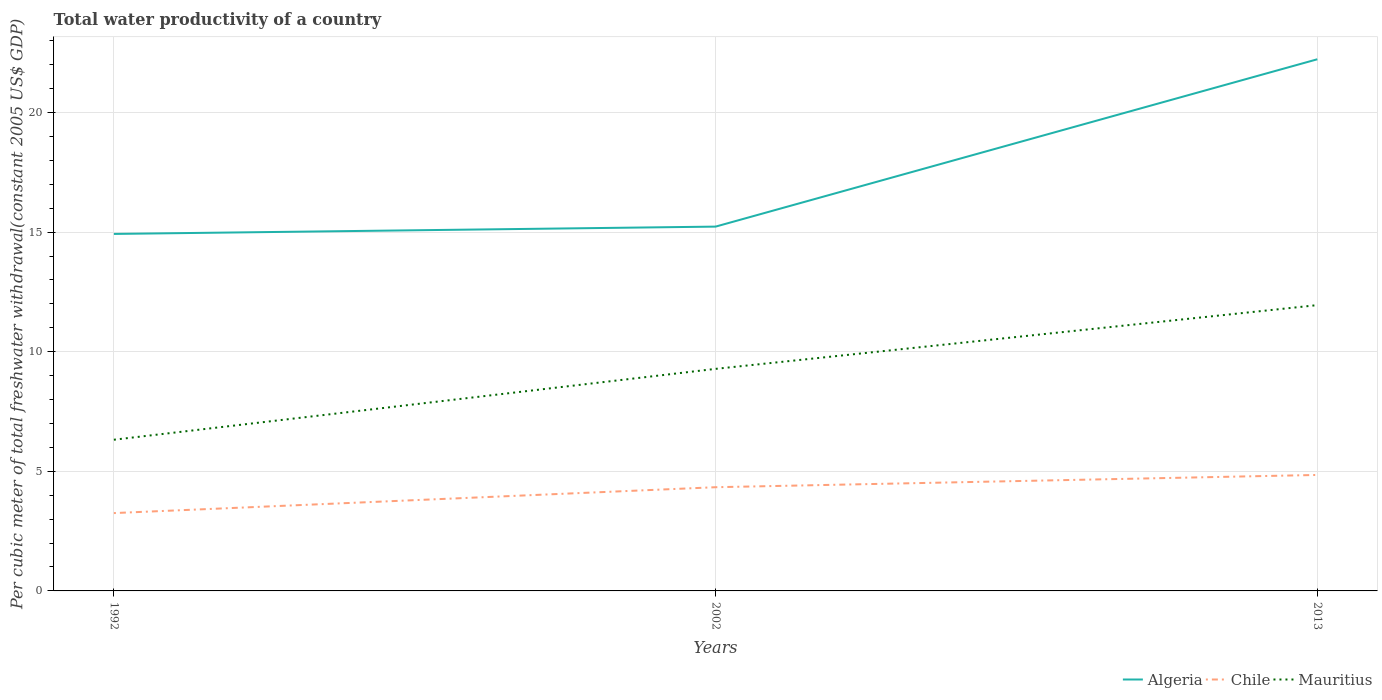How many different coloured lines are there?
Offer a very short reply. 3. Does the line corresponding to Algeria intersect with the line corresponding to Mauritius?
Provide a short and direct response. No. Across all years, what is the maximum total water productivity in Chile?
Your response must be concise. 3.25. What is the total total water productivity in Chile in the graph?
Offer a very short reply. -1.59. What is the difference between the highest and the second highest total water productivity in Algeria?
Offer a very short reply. 7.3. How many years are there in the graph?
Give a very brief answer. 3. Does the graph contain any zero values?
Offer a terse response. No. What is the title of the graph?
Ensure brevity in your answer.  Total water productivity of a country. Does "Syrian Arab Republic" appear as one of the legend labels in the graph?
Keep it short and to the point. No. What is the label or title of the X-axis?
Offer a terse response. Years. What is the label or title of the Y-axis?
Your answer should be compact. Per cubic meter of total freshwater withdrawal(constant 2005 US$ GDP). What is the Per cubic meter of total freshwater withdrawal(constant 2005 US$ GDP) of Algeria in 1992?
Your answer should be very brief. 14.92. What is the Per cubic meter of total freshwater withdrawal(constant 2005 US$ GDP) in Chile in 1992?
Ensure brevity in your answer.  3.25. What is the Per cubic meter of total freshwater withdrawal(constant 2005 US$ GDP) of Mauritius in 1992?
Your answer should be compact. 6.32. What is the Per cubic meter of total freshwater withdrawal(constant 2005 US$ GDP) of Algeria in 2002?
Your answer should be very brief. 15.23. What is the Per cubic meter of total freshwater withdrawal(constant 2005 US$ GDP) of Chile in 2002?
Give a very brief answer. 4.34. What is the Per cubic meter of total freshwater withdrawal(constant 2005 US$ GDP) of Mauritius in 2002?
Keep it short and to the point. 9.28. What is the Per cubic meter of total freshwater withdrawal(constant 2005 US$ GDP) in Algeria in 2013?
Offer a terse response. 22.22. What is the Per cubic meter of total freshwater withdrawal(constant 2005 US$ GDP) in Chile in 2013?
Provide a succinct answer. 4.85. What is the Per cubic meter of total freshwater withdrawal(constant 2005 US$ GDP) in Mauritius in 2013?
Offer a terse response. 11.95. Across all years, what is the maximum Per cubic meter of total freshwater withdrawal(constant 2005 US$ GDP) in Algeria?
Make the answer very short. 22.22. Across all years, what is the maximum Per cubic meter of total freshwater withdrawal(constant 2005 US$ GDP) of Chile?
Offer a very short reply. 4.85. Across all years, what is the maximum Per cubic meter of total freshwater withdrawal(constant 2005 US$ GDP) of Mauritius?
Your response must be concise. 11.95. Across all years, what is the minimum Per cubic meter of total freshwater withdrawal(constant 2005 US$ GDP) of Algeria?
Provide a short and direct response. 14.92. Across all years, what is the minimum Per cubic meter of total freshwater withdrawal(constant 2005 US$ GDP) of Chile?
Make the answer very short. 3.25. Across all years, what is the minimum Per cubic meter of total freshwater withdrawal(constant 2005 US$ GDP) in Mauritius?
Your answer should be very brief. 6.32. What is the total Per cubic meter of total freshwater withdrawal(constant 2005 US$ GDP) in Algeria in the graph?
Your response must be concise. 52.38. What is the total Per cubic meter of total freshwater withdrawal(constant 2005 US$ GDP) in Chile in the graph?
Your answer should be very brief. 12.44. What is the total Per cubic meter of total freshwater withdrawal(constant 2005 US$ GDP) of Mauritius in the graph?
Your answer should be compact. 27.55. What is the difference between the Per cubic meter of total freshwater withdrawal(constant 2005 US$ GDP) of Algeria in 1992 and that in 2002?
Provide a succinct answer. -0.31. What is the difference between the Per cubic meter of total freshwater withdrawal(constant 2005 US$ GDP) in Chile in 1992 and that in 2002?
Make the answer very short. -1.08. What is the difference between the Per cubic meter of total freshwater withdrawal(constant 2005 US$ GDP) in Mauritius in 1992 and that in 2002?
Your answer should be compact. -2.96. What is the difference between the Per cubic meter of total freshwater withdrawal(constant 2005 US$ GDP) of Algeria in 1992 and that in 2013?
Provide a short and direct response. -7.3. What is the difference between the Per cubic meter of total freshwater withdrawal(constant 2005 US$ GDP) in Chile in 1992 and that in 2013?
Ensure brevity in your answer.  -1.59. What is the difference between the Per cubic meter of total freshwater withdrawal(constant 2005 US$ GDP) in Mauritius in 1992 and that in 2013?
Provide a succinct answer. -5.63. What is the difference between the Per cubic meter of total freshwater withdrawal(constant 2005 US$ GDP) of Algeria in 2002 and that in 2013?
Keep it short and to the point. -7. What is the difference between the Per cubic meter of total freshwater withdrawal(constant 2005 US$ GDP) of Chile in 2002 and that in 2013?
Provide a succinct answer. -0.51. What is the difference between the Per cubic meter of total freshwater withdrawal(constant 2005 US$ GDP) of Mauritius in 2002 and that in 2013?
Ensure brevity in your answer.  -2.66. What is the difference between the Per cubic meter of total freshwater withdrawal(constant 2005 US$ GDP) of Algeria in 1992 and the Per cubic meter of total freshwater withdrawal(constant 2005 US$ GDP) of Chile in 2002?
Make the answer very short. 10.59. What is the difference between the Per cubic meter of total freshwater withdrawal(constant 2005 US$ GDP) of Algeria in 1992 and the Per cubic meter of total freshwater withdrawal(constant 2005 US$ GDP) of Mauritius in 2002?
Provide a succinct answer. 5.64. What is the difference between the Per cubic meter of total freshwater withdrawal(constant 2005 US$ GDP) in Chile in 1992 and the Per cubic meter of total freshwater withdrawal(constant 2005 US$ GDP) in Mauritius in 2002?
Ensure brevity in your answer.  -6.03. What is the difference between the Per cubic meter of total freshwater withdrawal(constant 2005 US$ GDP) in Algeria in 1992 and the Per cubic meter of total freshwater withdrawal(constant 2005 US$ GDP) in Chile in 2013?
Your answer should be very brief. 10.07. What is the difference between the Per cubic meter of total freshwater withdrawal(constant 2005 US$ GDP) of Algeria in 1992 and the Per cubic meter of total freshwater withdrawal(constant 2005 US$ GDP) of Mauritius in 2013?
Offer a very short reply. 2.98. What is the difference between the Per cubic meter of total freshwater withdrawal(constant 2005 US$ GDP) in Chile in 1992 and the Per cubic meter of total freshwater withdrawal(constant 2005 US$ GDP) in Mauritius in 2013?
Ensure brevity in your answer.  -8.69. What is the difference between the Per cubic meter of total freshwater withdrawal(constant 2005 US$ GDP) of Algeria in 2002 and the Per cubic meter of total freshwater withdrawal(constant 2005 US$ GDP) of Chile in 2013?
Give a very brief answer. 10.38. What is the difference between the Per cubic meter of total freshwater withdrawal(constant 2005 US$ GDP) of Algeria in 2002 and the Per cubic meter of total freshwater withdrawal(constant 2005 US$ GDP) of Mauritius in 2013?
Ensure brevity in your answer.  3.28. What is the difference between the Per cubic meter of total freshwater withdrawal(constant 2005 US$ GDP) in Chile in 2002 and the Per cubic meter of total freshwater withdrawal(constant 2005 US$ GDP) in Mauritius in 2013?
Offer a very short reply. -7.61. What is the average Per cubic meter of total freshwater withdrawal(constant 2005 US$ GDP) in Algeria per year?
Your response must be concise. 17.46. What is the average Per cubic meter of total freshwater withdrawal(constant 2005 US$ GDP) of Chile per year?
Provide a succinct answer. 4.15. What is the average Per cubic meter of total freshwater withdrawal(constant 2005 US$ GDP) in Mauritius per year?
Make the answer very short. 9.18. In the year 1992, what is the difference between the Per cubic meter of total freshwater withdrawal(constant 2005 US$ GDP) in Algeria and Per cubic meter of total freshwater withdrawal(constant 2005 US$ GDP) in Chile?
Offer a terse response. 11.67. In the year 1992, what is the difference between the Per cubic meter of total freshwater withdrawal(constant 2005 US$ GDP) of Algeria and Per cubic meter of total freshwater withdrawal(constant 2005 US$ GDP) of Mauritius?
Provide a succinct answer. 8.6. In the year 1992, what is the difference between the Per cubic meter of total freshwater withdrawal(constant 2005 US$ GDP) in Chile and Per cubic meter of total freshwater withdrawal(constant 2005 US$ GDP) in Mauritius?
Make the answer very short. -3.07. In the year 2002, what is the difference between the Per cubic meter of total freshwater withdrawal(constant 2005 US$ GDP) in Algeria and Per cubic meter of total freshwater withdrawal(constant 2005 US$ GDP) in Chile?
Make the answer very short. 10.89. In the year 2002, what is the difference between the Per cubic meter of total freshwater withdrawal(constant 2005 US$ GDP) in Algeria and Per cubic meter of total freshwater withdrawal(constant 2005 US$ GDP) in Mauritius?
Your answer should be very brief. 5.95. In the year 2002, what is the difference between the Per cubic meter of total freshwater withdrawal(constant 2005 US$ GDP) in Chile and Per cubic meter of total freshwater withdrawal(constant 2005 US$ GDP) in Mauritius?
Provide a succinct answer. -4.95. In the year 2013, what is the difference between the Per cubic meter of total freshwater withdrawal(constant 2005 US$ GDP) of Algeria and Per cubic meter of total freshwater withdrawal(constant 2005 US$ GDP) of Chile?
Provide a short and direct response. 17.38. In the year 2013, what is the difference between the Per cubic meter of total freshwater withdrawal(constant 2005 US$ GDP) in Algeria and Per cubic meter of total freshwater withdrawal(constant 2005 US$ GDP) in Mauritius?
Provide a succinct answer. 10.28. In the year 2013, what is the difference between the Per cubic meter of total freshwater withdrawal(constant 2005 US$ GDP) in Chile and Per cubic meter of total freshwater withdrawal(constant 2005 US$ GDP) in Mauritius?
Ensure brevity in your answer.  -7.1. What is the ratio of the Per cubic meter of total freshwater withdrawal(constant 2005 US$ GDP) in Algeria in 1992 to that in 2002?
Ensure brevity in your answer.  0.98. What is the ratio of the Per cubic meter of total freshwater withdrawal(constant 2005 US$ GDP) of Chile in 1992 to that in 2002?
Make the answer very short. 0.75. What is the ratio of the Per cubic meter of total freshwater withdrawal(constant 2005 US$ GDP) in Mauritius in 1992 to that in 2002?
Your answer should be very brief. 0.68. What is the ratio of the Per cubic meter of total freshwater withdrawal(constant 2005 US$ GDP) of Algeria in 1992 to that in 2013?
Provide a succinct answer. 0.67. What is the ratio of the Per cubic meter of total freshwater withdrawal(constant 2005 US$ GDP) in Chile in 1992 to that in 2013?
Your response must be concise. 0.67. What is the ratio of the Per cubic meter of total freshwater withdrawal(constant 2005 US$ GDP) in Mauritius in 1992 to that in 2013?
Offer a terse response. 0.53. What is the ratio of the Per cubic meter of total freshwater withdrawal(constant 2005 US$ GDP) in Algeria in 2002 to that in 2013?
Your answer should be very brief. 0.69. What is the ratio of the Per cubic meter of total freshwater withdrawal(constant 2005 US$ GDP) of Chile in 2002 to that in 2013?
Your response must be concise. 0.89. What is the ratio of the Per cubic meter of total freshwater withdrawal(constant 2005 US$ GDP) in Mauritius in 2002 to that in 2013?
Your answer should be compact. 0.78. What is the difference between the highest and the second highest Per cubic meter of total freshwater withdrawal(constant 2005 US$ GDP) in Algeria?
Provide a succinct answer. 7. What is the difference between the highest and the second highest Per cubic meter of total freshwater withdrawal(constant 2005 US$ GDP) of Chile?
Offer a terse response. 0.51. What is the difference between the highest and the second highest Per cubic meter of total freshwater withdrawal(constant 2005 US$ GDP) in Mauritius?
Offer a very short reply. 2.66. What is the difference between the highest and the lowest Per cubic meter of total freshwater withdrawal(constant 2005 US$ GDP) in Algeria?
Offer a terse response. 7.3. What is the difference between the highest and the lowest Per cubic meter of total freshwater withdrawal(constant 2005 US$ GDP) of Chile?
Offer a terse response. 1.59. What is the difference between the highest and the lowest Per cubic meter of total freshwater withdrawal(constant 2005 US$ GDP) in Mauritius?
Offer a terse response. 5.63. 